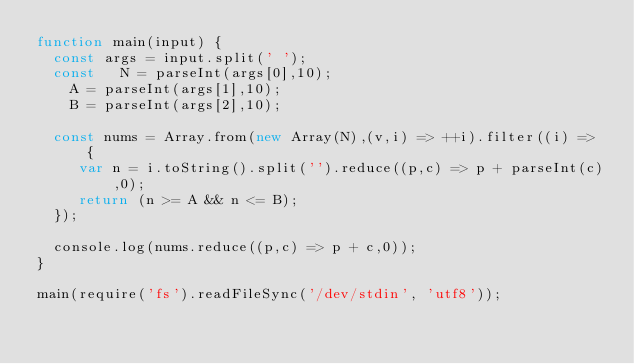Convert code to text. <code><loc_0><loc_0><loc_500><loc_500><_JavaScript_>function main(input) {
	const args = input.split(' ');
	const 	N = parseInt(args[0],10);
		A = parseInt(args[1],10);
		B = parseInt(args[2],10);

	const nums = Array.from(new Array(N),(v,i) => ++i).filter((i) => {
	   var n = i.toString().split('').reduce((p,c) => p + parseInt(c),0);
	   return (n >= A && n <= B);	
	});

	console.log(nums.reduce((p,c) => p + c,0));
}

main(require('fs').readFileSync('/dev/stdin', 'utf8'));

</code> 